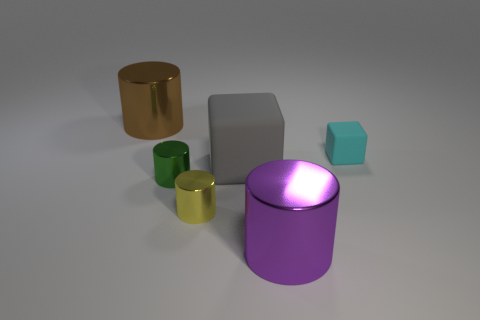What number of tiny yellow rubber spheres are there?
Your answer should be very brief. 0. How many balls are either purple metal things or gray matte objects?
Give a very brief answer. 0. There is a large metallic object that is behind the purple cylinder; what number of big cylinders are in front of it?
Give a very brief answer. 1. Are the small cyan cube and the tiny yellow thing made of the same material?
Ensure brevity in your answer.  No. Are there any gray cubes made of the same material as the small cyan block?
Provide a short and direct response. Yes. There is a big metallic cylinder left of the rubber thing in front of the cube that is on the right side of the big purple shiny thing; what color is it?
Ensure brevity in your answer.  Brown. How many red things are either big blocks or large metallic objects?
Provide a short and direct response. 0. What number of other things are the same shape as the large gray rubber thing?
Provide a short and direct response. 1. What shape is the gray object that is the same size as the purple cylinder?
Offer a very short reply. Cube. Are there any tiny matte blocks behind the tiny matte object?
Give a very brief answer. No. 